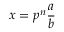<formula> <loc_0><loc_0><loc_500><loc_500>x = p ^ { n } { \frac { a } { b } }</formula> 